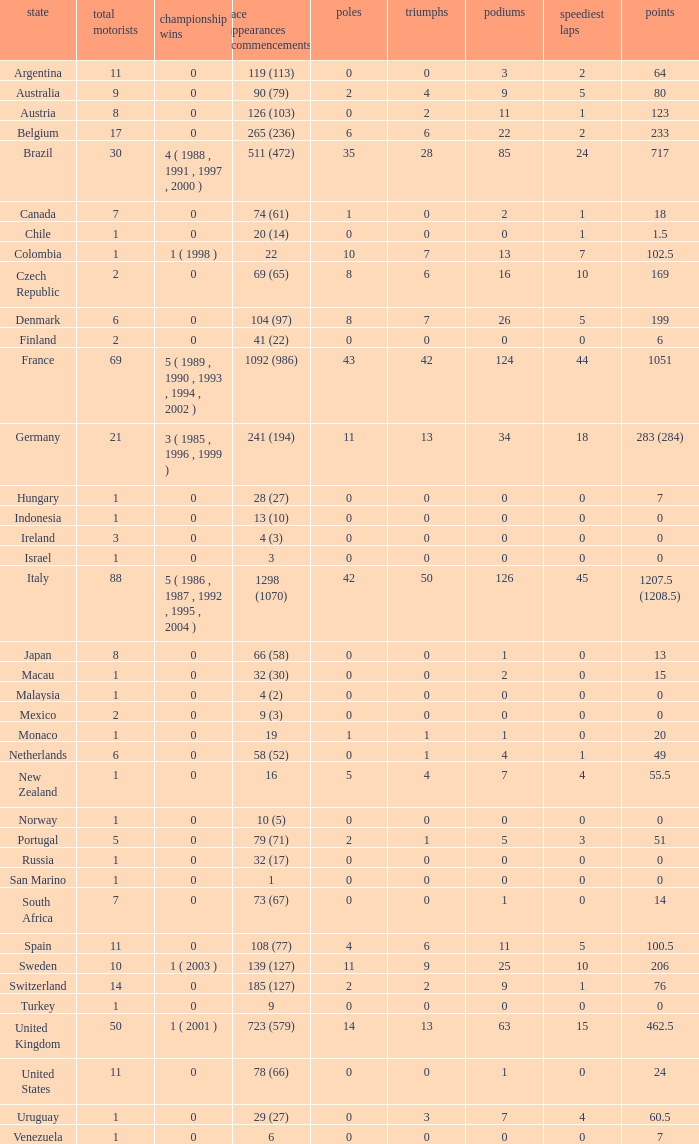How many titles for the nation with less than 3 fastest laps and 22 podiums? 0.0. 